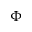Convert formula to latex. <formula><loc_0><loc_0><loc_500><loc_500>\Phi</formula> 